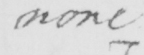Please provide the text content of this handwritten line. none . 